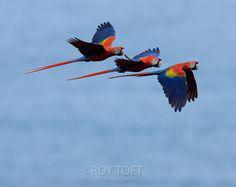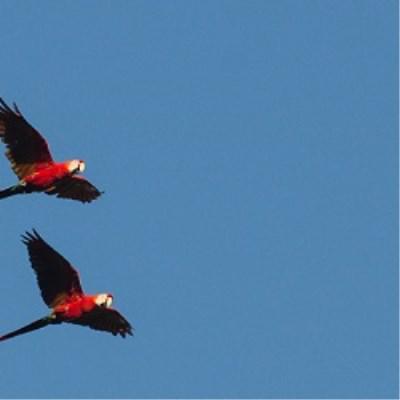The first image is the image on the left, the second image is the image on the right. Given the left and right images, does the statement "There are 4 or more parrots flying to the right." hold true? Answer yes or no. Yes. 